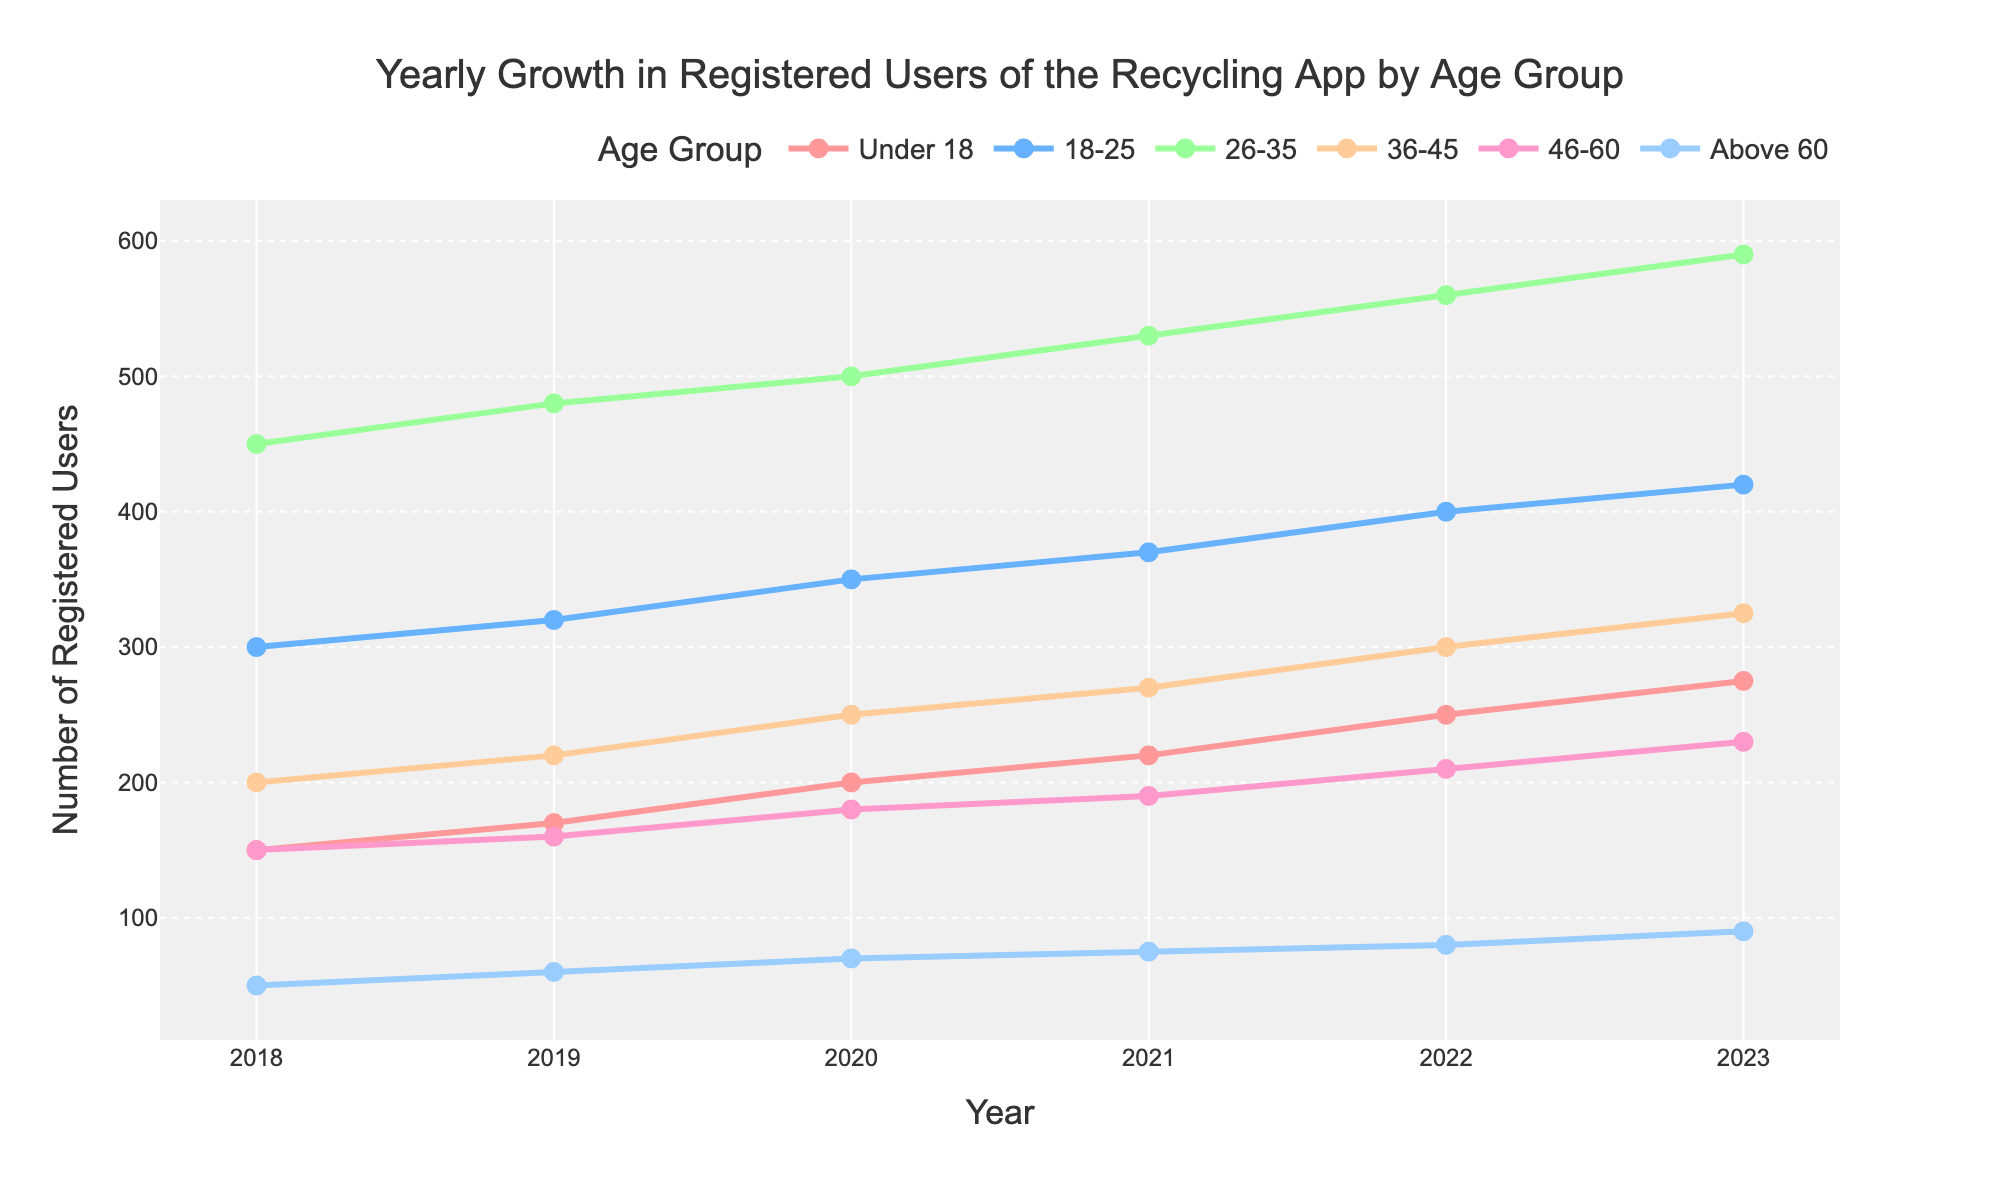what is the total number of registered users in 2023 across all age groups? To find the total number of registered users in 2023, add the values of all age groups for that year. 275 (Under 18) + 420 (18-25) + 590 (26-35) + 325 (36-45) + 230 (46-60) + 90 (Above 60) = 1930
Answer: 1930 which age group had the highest growth in registered users between 2018 and 2023? Find the difference in registered users for each age group between 2018 and 2023, then identify the largest difference. Under 18: (275-150)=125, 18-25: (420-300)=120, 26-35: (590-450)=140, 36-45: (325-200)=125, 46-60: (230-150)=80, Above 60: (90-50)=40. The highest growth was in the 26-35 age group with an increase of 140
Answer: 26-35 in which year did the 18-25 age group surpass 400 registered users? Check the value for the 18-25 age group each year and find the first occurrence surpassing 400. The value surpasses 400 in the year 2022
Answer: 2022 how did the number of registered users in the 46-60 age group change from 2018 to 2023? Calculate the difference in registered users in the 46-60 age group between 2018 and 2023. 230 (in 2023) - 150 (in 2018) = 80
Answer: increased by 80 which age group had the smallest increase in registered users from 2018 to 2023? Calculate the increase for each age group by subtracting 2018 values from 2023 values and compare. Under 18: 125, 18-25: 120, 26-35: 140, 36-45: 125, 46-60: 80, Above 60: 40. The smallest increase is in the Above 60 age group with an increase of 40
Answer: Above 60 which age group remained closest in user count throughout the years? Check the values across years for each age group and see if they have close numbers rather than wide variations. The 46-60 age group varies between 150 and 230, demonstrating relatively stable numbers compared to larger ranges in other groups
Answer: 46-60 in what year did the 36-45 age group exceed 250 registered users? Look for the first year where the value for the 36-45 age group exceeds 250. This occurred in 2020
Answer: 2020 by how much did the number of registered users in the Under 18 age group change between 2020 and 2023? Calculate the difference in registered users for the Under 18 age group between these years. 275 (in 2023) - 200 (in 2020) = 75
Answer: 75 